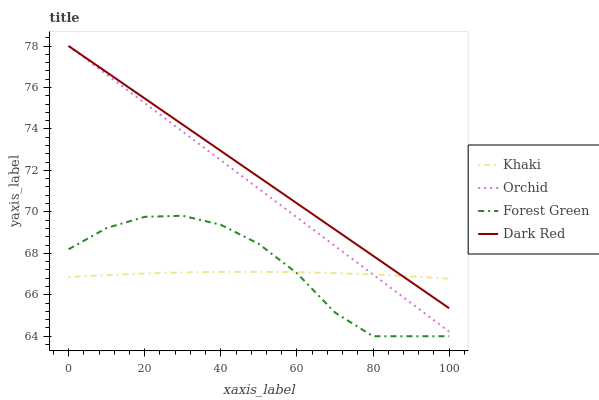Does Khaki have the minimum area under the curve?
Answer yes or no. Yes. Does Dark Red have the maximum area under the curve?
Answer yes or no. Yes. Does Forest Green have the minimum area under the curve?
Answer yes or no. No. Does Forest Green have the maximum area under the curve?
Answer yes or no. No. Is Orchid the smoothest?
Answer yes or no. Yes. Is Forest Green the roughest?
Answer yes or no. Yes. Is Khaki the smoothest?
Answer yes or no. No. Is Khaki the roughest?
Answer yes or no. No. Does Forest Green have the lowest value?
Answer yes or no. Yes. Does Khaki have the lowest value?
Answer yes or no. No. Does Orchid have the highest value?
Answer yes or no. Yes. Does Forest Green have the highest value?
Answer yes or no. No. Is Forest Green less than Orchid?
Answer yes or no. Yes. Is Orchid greater than Forest Green?
Answer yes or no. Yes. Does Khaki intersect Dark Red?
Answer yes or no. Yes. Is Khaki less than Dark Red?
Answer yes or no. No. Is Khaki greater than Dark Red?
Answer yes or no. No. Does Forest Green intersect Orchid?
Answer yes or no. No. 